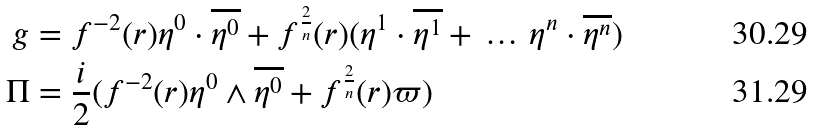<formula> <loc_0><loc_0><loc_500><loc_500>g & = f ^ { - 2 } ( r ) \eta ^ { 0 } \cdot \overline { \eta ^ { 0 } } + f ^ { \frac { 2 } { n } } ( r ) ( \eta ^ { 1 } \cdot \overline { \eta ^ { 1 } } + \, \dots \, \eta ^ { n } \cdot \overline { \eta ^ { n } } ) \\ \Pi & = \frac { i } { 2 } ( f ^ { - 2 } ( r ) \eta ^ { 0 } \wedge \overline { \eta ^ { 0 } } + f ^ { \frac { 2 } { n } } ( r ) \varpi )</formula> 